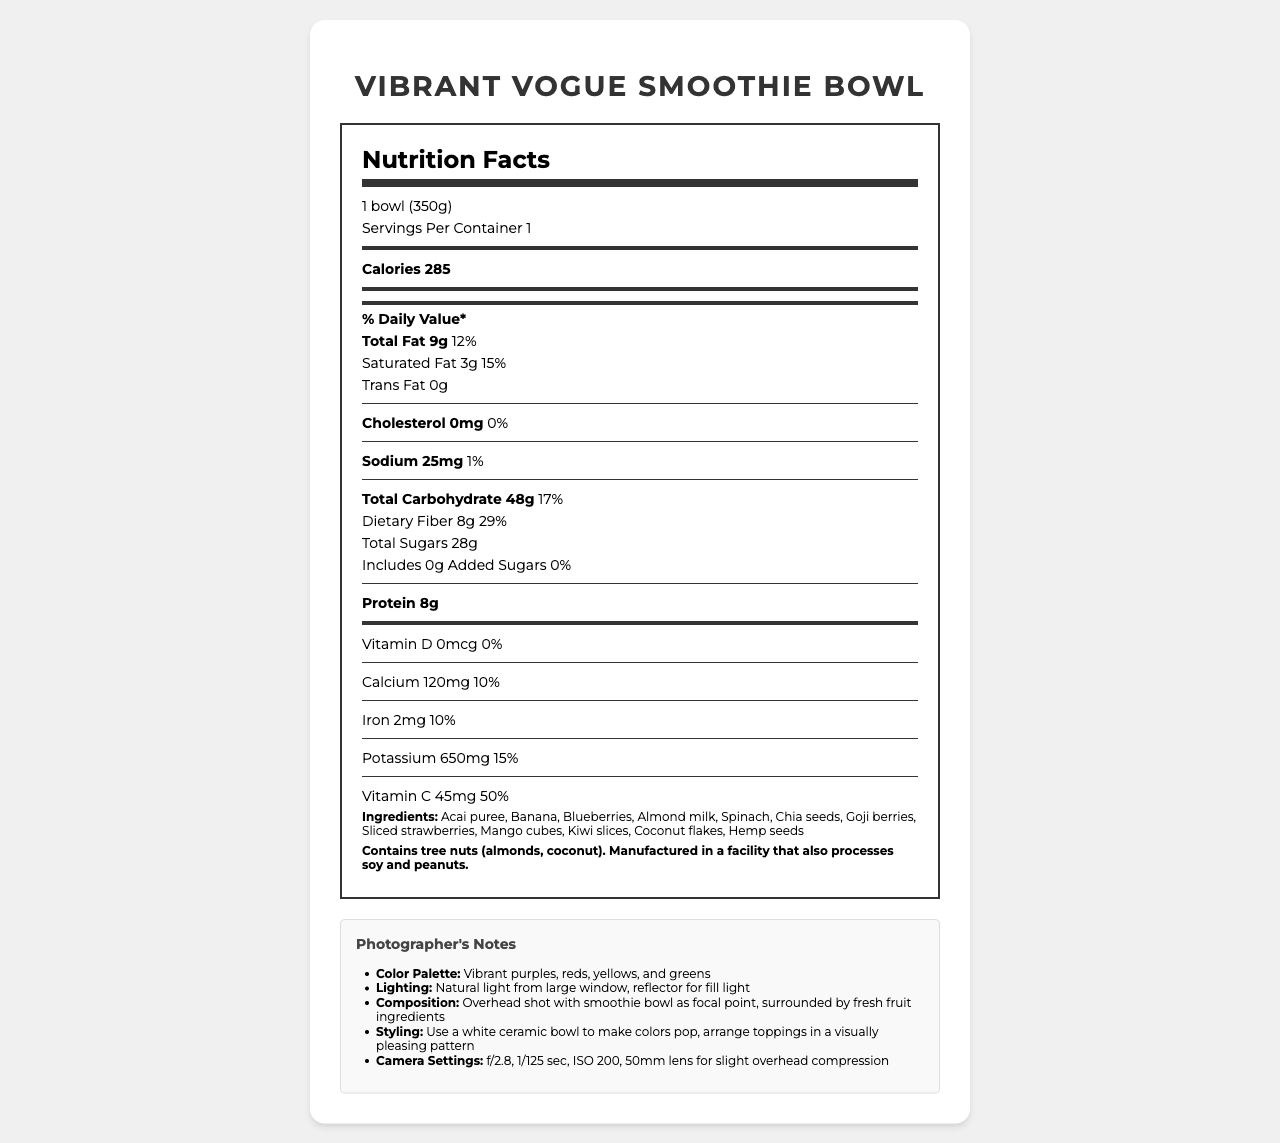what is the serving size of the Vibrant Vogue Smoothie Bowl? The serving size is clearly stated in the nutrition label section as "1 bowl (350g)".
Answer: 1 bowl (350g) how many calories are in one serving of the Vibrant Vogue Smoothie Bowl? The nutrition label specifies that there are 285 calories in one serving.
Answer: 285 calories what is the amount of protein in the Vibrant Vogue Smoothie Bowl? According to the nutrition label, the Vibrant Vogue Smoothie Bowl contains 8g of protein per serving.
Answer: 8g how much dietary fiber is in the smoothie bowl? The nutrition label lists 8g of dietary fiber in one serving of the smoothie bowl.
Answer: 8g what are the total sugars content of the Vibrant Vogue Smoothie Bowl? The label indicates that there are 28g of total sugars in one serving.
Answer: 28g which vitamins and minerals provide 10% of the daily value in the smoothie bowl? The nutrition label shows that Calcium (120mg) and Iron (2mg) each provide 10% of the daily value.
Answer: Calcium and Iron what type of light setup is recommended for photographing the smoothie bowl? The photographer's notes specify using natural light from a large window and a reflector for fill light.
Answer: Natural light from large window, reflector for fill light what is the main styling tip given for photographing the smoothie bowl? A. Use a green ceramic bowl B. Arrange toppings randomly C. Use a white ceramic bowl to make colors pop The document suggests using a white ceramic bowl to make the colors pop.
Answer: C what is the suggested camera settings for capturing the smoothie bowl? 1. f/2.8, 1/50 sec, ISO 100 2. f/2.8, 1/125 sec, ISO 200 3. f/3.5, 1/200 sec, ISO 400 The photographer's notes indicate that the recommended camera settings are f/2.8, 1/125 sec, and ISO 200.
Answer: 2. f/2.8, 1/125 sec, ISO 200 does the smoothie bowl contain any added sugars? The label states "Includes 0g Added Sugars", indicating there are no added sugars.
Answer: No summarize the main idea of the document. The document includes comprehensive details on the nutritional content of the smoothie bowl, the ingredients list, allergen information, and specific photographer’s notes for capturing visually appealing images of the product.
Answer: The document provides nutritional information, ingredients, allergen information, and photographer's notes for the Vibrant Vogue Smoothie Bowl. It details the calories, macronutrients, vitamins, and minerals in the smoothie bowl, along with tips for photographing the product. is this product suitable for someone with a peanut allergy? While the product itself does not contain peanuts, it is manufactured in a facility that processes peanuts, thus it may not be safe for someone with a peanut allergy.
Answer: Cannot be determined what percentage of the daily value for vitamin c does the smoothie bowl provide? The nutrition label states that the smoothie bowl provides 50% of the daily value for Vitamin C.
Answer: 50% how much potassium is in the smoothie bowl and what percentage of the daily value does it represent? The nutrition label shows that there are 650mg of potassium, which represents 15% of the daily value.
Answer: 650mg, 15% 